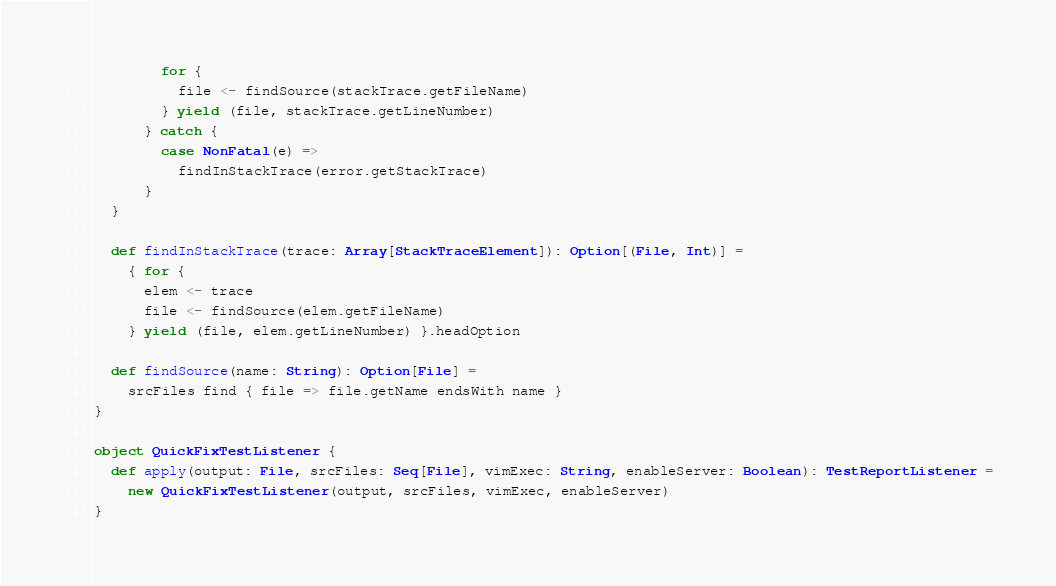Convert code to text. <code><loc_0><loc_0><loc_500><loc_500><_Scala_>        for {
          file <- findSource(stackTrace.getFileName)
        } yield (file, stackTrace.getLineNumber)
      } catch {
        case NonFatal(e) =>
          findInStackTrace(error.getStackTrace)
      }
  }

  def findInStackTrace(trace: Array[StackTraceElement]): Option[(File, Int)] =
    { for {
      elem <- trace
      file <- findSource(elem.getFileName)
    } yield (file, elem.getLineNumber) }.headOption

  def findSource(name: String): Option[File] =
    srcFiles find { file => file.getName endsWith name }
}

object QuickFixTestListener {
  def apply(output: File, srcFiles: Seq[File], vimExec: String, enableServer: Boolean): TestReportListener =
    new QuickFixTestListener(output, srcFiles, vimExec, enableServer)
}
</code> 